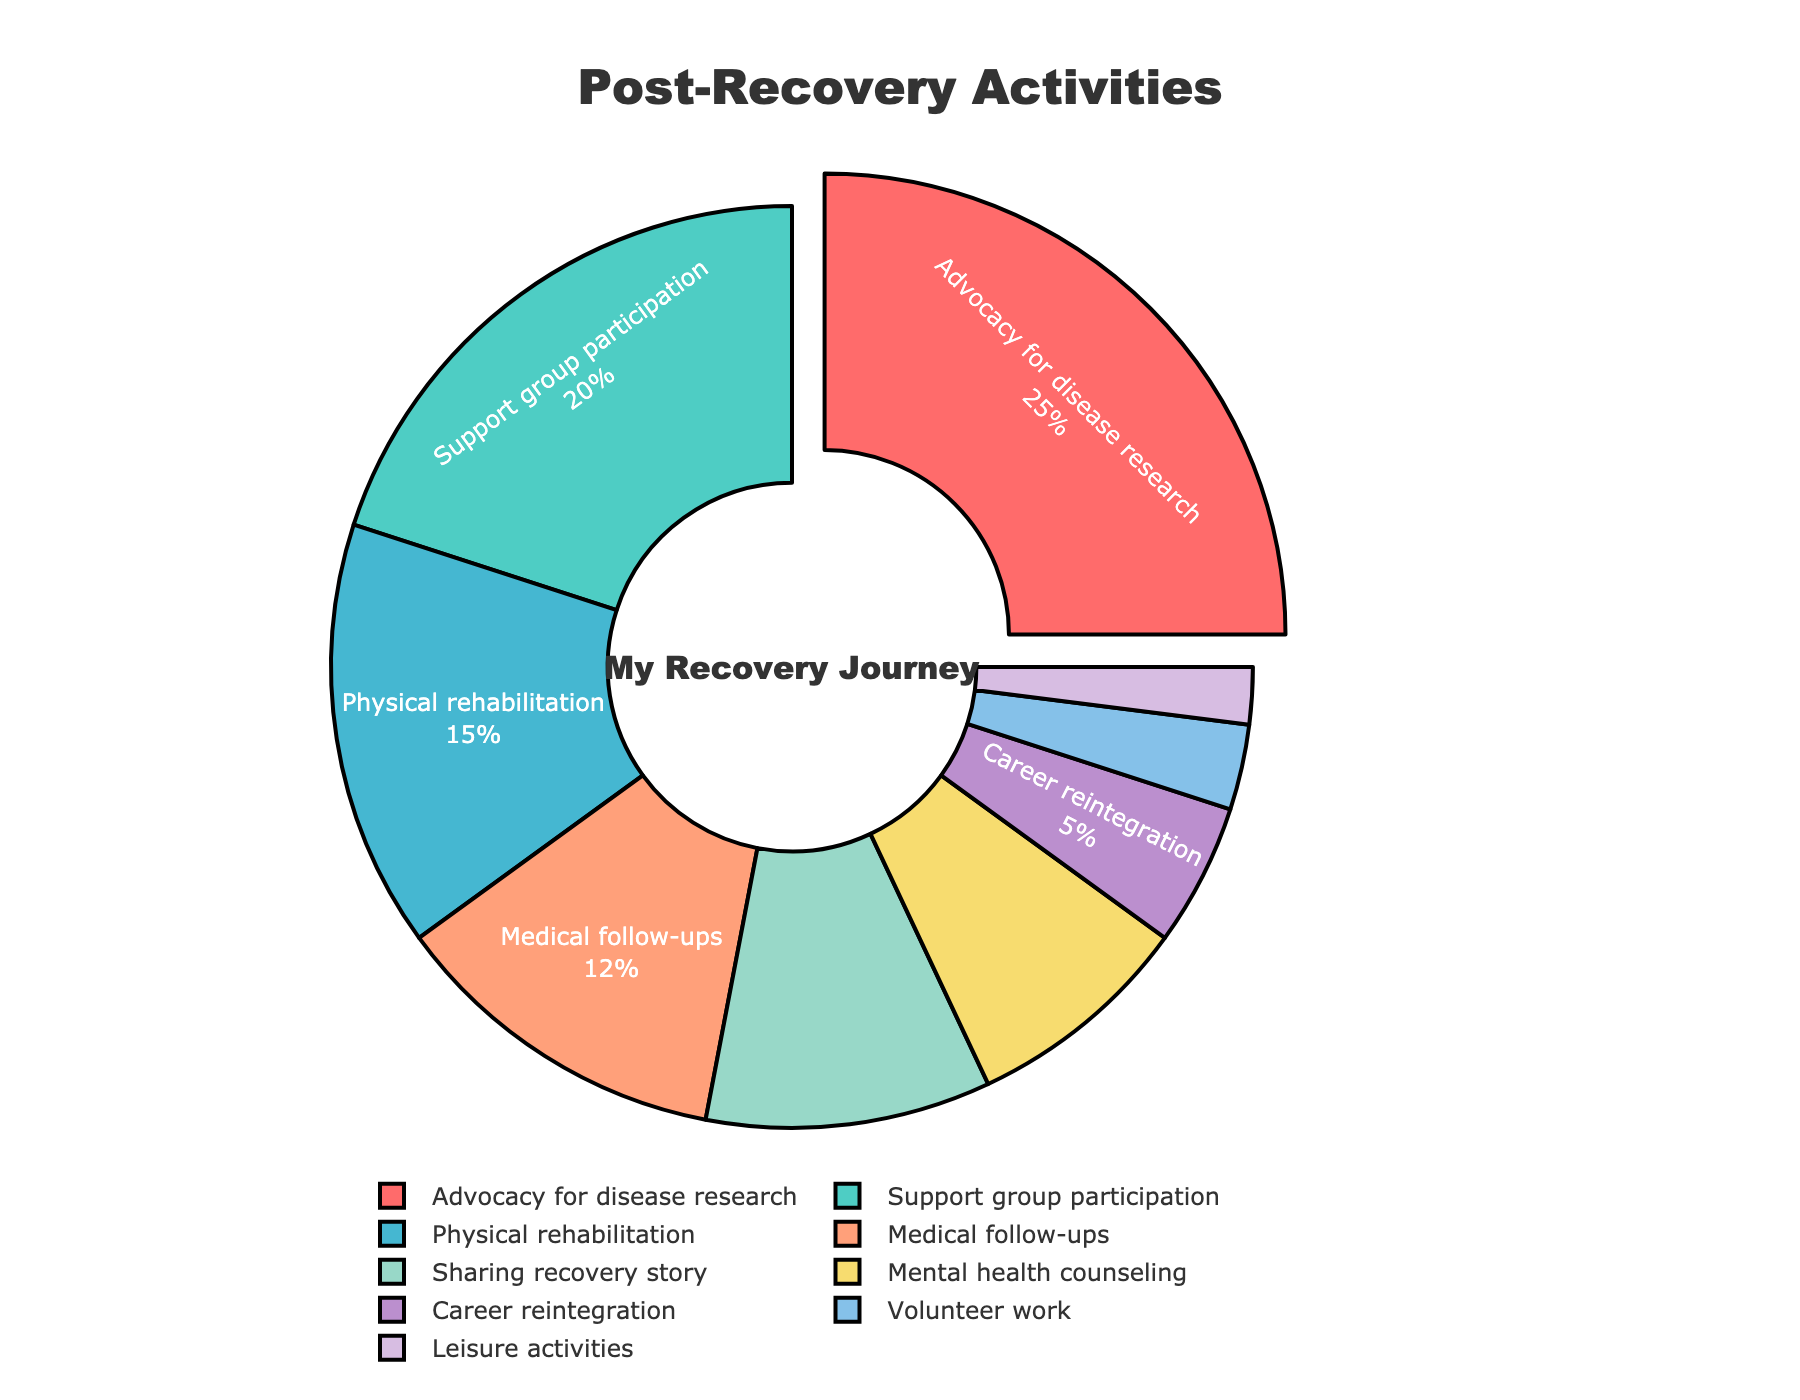What's the most time-consuming post-recovery activity? Look for the largest slice of the pie chart. The slice labeled "Advocacy for disease research" takes up 25% of the pie, which is the largest portion.
Answer: Advocacy for disease research Which activity is given the least amount of time? Identify the smallest slice in the pie chart. The smallest slice is labeled "Leisure activities" with 2%.
Answer: Leisure activities What is the combined percentage of time spent on Advocacy for disease research and Support group participation? Add the percentages of the two activities: Advocacy for disease research (25%) and Support group participation (20%). 25% + 20% = 45%.
Answer: 45% How does the time spent on Medical follow-ups compare to Career reintegration? Compare the percentages given. Medical follow-ups have 12%, while Career reintegration has 5%. 12% is more than 5%.
Answer: Medical follow-ups > Career reintegration What is the percentage difference between Physical rehabilitation and Mental health counseling? Subtract the smaller percentage (Mental health counseling, 8%) from the larger percentage (Physical rehabilitation, 15%). 15% - 8% = 7%.
Answer: 7% Which activity has a bright red color in the chart? Look for the slice with the bright red color. The red slice corresponds to "Advocacy for disease research".
Answer: Advocacy for disease research What proportion of time is spent on Medical follow-ups, Sharing recovery story, and Career reintegration combined? Add the percentages of the three activities: Medical follow-ups (12%), Sharing recovery story (10%), Career reintegration (5%). 12% + 10% + 5% = 27%.
Answer: 27% Is any activity allocated exactly double the percentage of another activity? If so, which activities? Compare the percentages of the activities to see if any activity's percentage is exactly double another's. "Physical rehabilitation" (15%) is double "Career reintegration" (5%), and "Sharing recovery story" (10%) is double "Leisure activities" (2%).
Answer: Physical rehabilitation and Career reintegration; Sharing recovery story and Leisure activities Which activities have a percentage allocated between 10% and 20%? Identify the activities with percentages between 10% and 20%. These are "Support group participation" (20%), "Physical rehabilitation" (15%), and "Medical follow-ups" (12%).
Answer: Support group participation, Physical rehabilitation, Medical follow-ups 